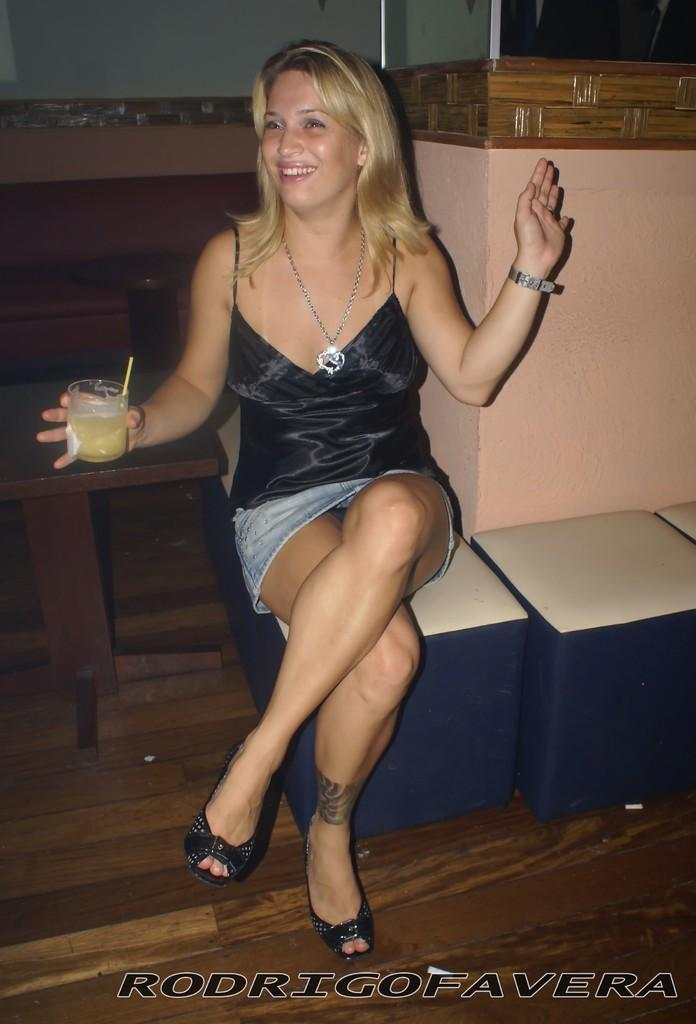Who is the main subject in the image? There is a woman in the image. What is the woman doing in the image? The woman is sitting on a stool. What is the woman wearing in the image? The woman is wearing a black dress. What is the woman holding in her right hand in the image? The woman is holding something in her right hand, but the specific object is not mentioned in the facts. What can be seen behind the woman in the image? There is a wall behind the woman. What type of waste can be seen in the image? There is no waste present in the image. How does the robin interact with the woman in the image? There is no robin present in the image. 